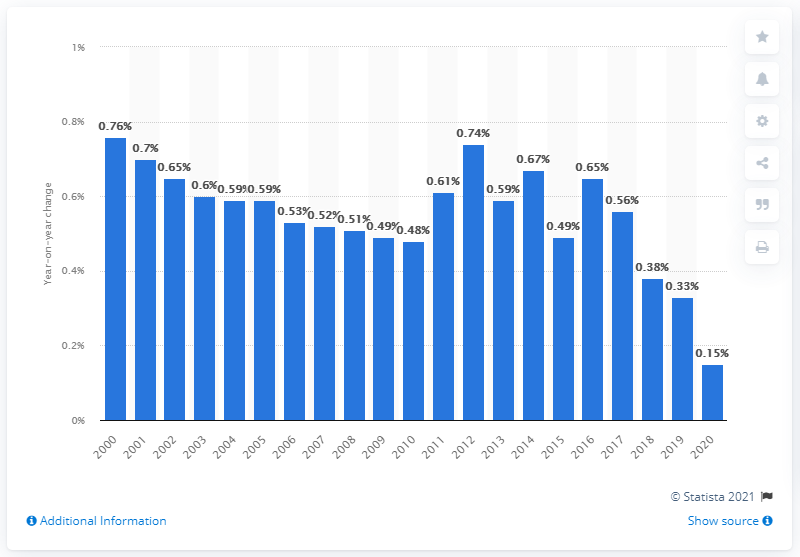Indicate a few pertinent items in this graphic. In 2020, the population growth in China was 0.15%. 